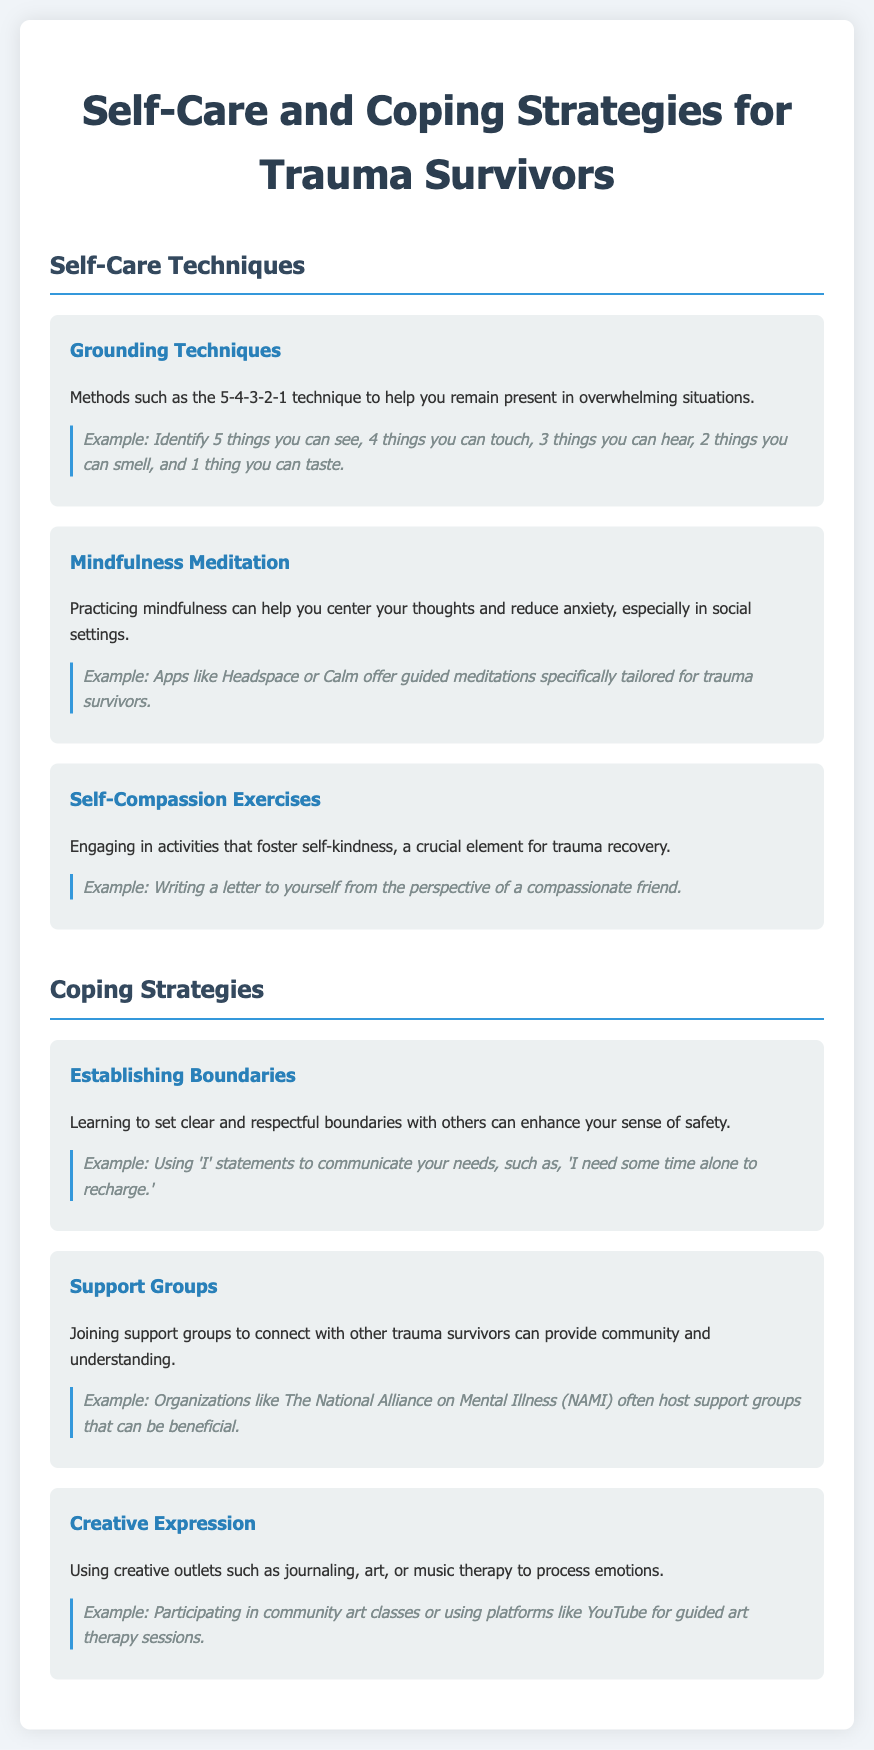What is the title of the document? The title is stated at the top of the document, indicating the subject matter.
Answer: Self-Care and Coping Strategies for Trauma Survivors How many self-care techniques are listed? The number of self-care techniques can be found by counting the sections under "Self-Care Techniques".
Answer: 3 What is the first coping strategy mentioned? The first coping strategy is listed under the heading of coping strategies.
Answer: Establishing Boundaries What technique uses the 5-4-3-2-1 approach? This specific technique is described in the document, detailing a method to remain present.
Answer: Grounding Techniques Which app is suggested for mindfulness meditation? The document refers to specific apps that help in mindfulness practices.
Answer: Headspace What type of expression is encouraged in creative outlets? The document provides examples of creative ways to process emotions.
Answer: Creative Expression What example is given for self-compassion exercises? The document includes an example related to self-kindness activities.
Answer: Writing a letter to yourself from the perspective of a compassionate friend How can support groups benefit trauma survivors? The document explains the advantages of connecting with others in similar circumstances.
Answer: Provide community and understanding 